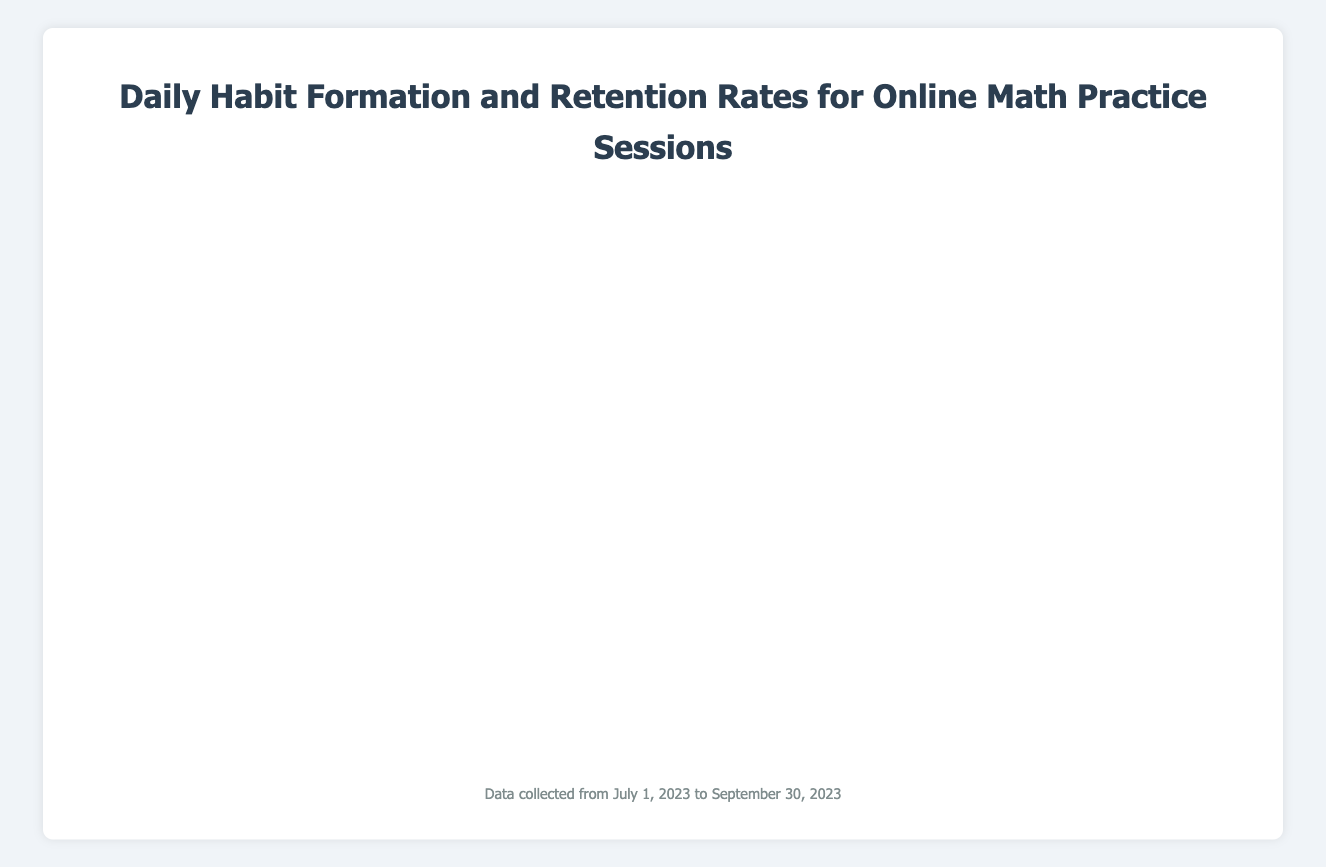What was the maximum number of sessions performed by Alice in a day, and on which date did it occur? Identify the highest peak in Alice’s line plot. The highest is 3 sessions per day. This occurred on several dates, such as 2023-07-05, 2023-07-20, and others. Refer to the plot’s specific dates with the highest value.
Answer: 3 sessions on 2023-07-05, 2023-07-20, and other dates Which user had the most consistent daily practice without any day-off during the first week of July? Look for a line plot where the line does not touch zero during the first week (2023-07-01 to 2023-07-07). Bob, Charlie, and David all had regular daily sessions during this period. However, in the context of consistency, Bob’s sessions were spread with fewer gaps.
Answer: Bob Who had more practice sessions in total in July: David or Eve? Sum up the total number of sessions for David and Eve in July (from 2023-07-01 to 2023-07-31). David's total is 34, while Eve's total is 40. Compare these totals to find who practiced more.
Answer: Eve with 40 sessions On average, how many daily sessions did all users perform in August? Sum up all daily sessions for all users through August (2023-08-01 to 2023-08-31), then divide by the number of days in August (31 days). The total aggregated can be calculated by summing up all the increments across users for August’s days and then dividing by 31.
Answer: Approximately 2 sessions per day Who showed the greatest variation in daily sessions throughout the quarter (July - September)? Check the visual fluctuations in the line plots for each user and identify whose plot shows the most ups and downs. More visually varying lines reflect greater variations. Alice shows the greatest variation with significant ups and downs.
Answer: Alice How did the overall number of daily sessions change from the beginning of July to the end of September for all users? Look at the general trend of the sum of all users' daily practices from the start to the end. Spot whether the graph indicates an overall upward or downward trend by visually assessing the aggregated height of the lines over time.
Answer: Slight upward trend Was there any day when all users had exactly one session? If so, please mention the date. Identify if there is a point in the graph where all the users’ values dipped down to exactly one at the same time. This wasn’t observed; no single date had all users at one session exactly on the same day.
Answer: No In September, on which date did Charlie have the highest number of sessions, and what was the value? Focus on Charlie’s line for the month of September (2023-09-01 to 2023-09-30) and identify the highest point on the line within this range. The highest value for Charlie is 3 sessions on 2023-09-03.
Answer: 3 sessions on 2023-09-03 